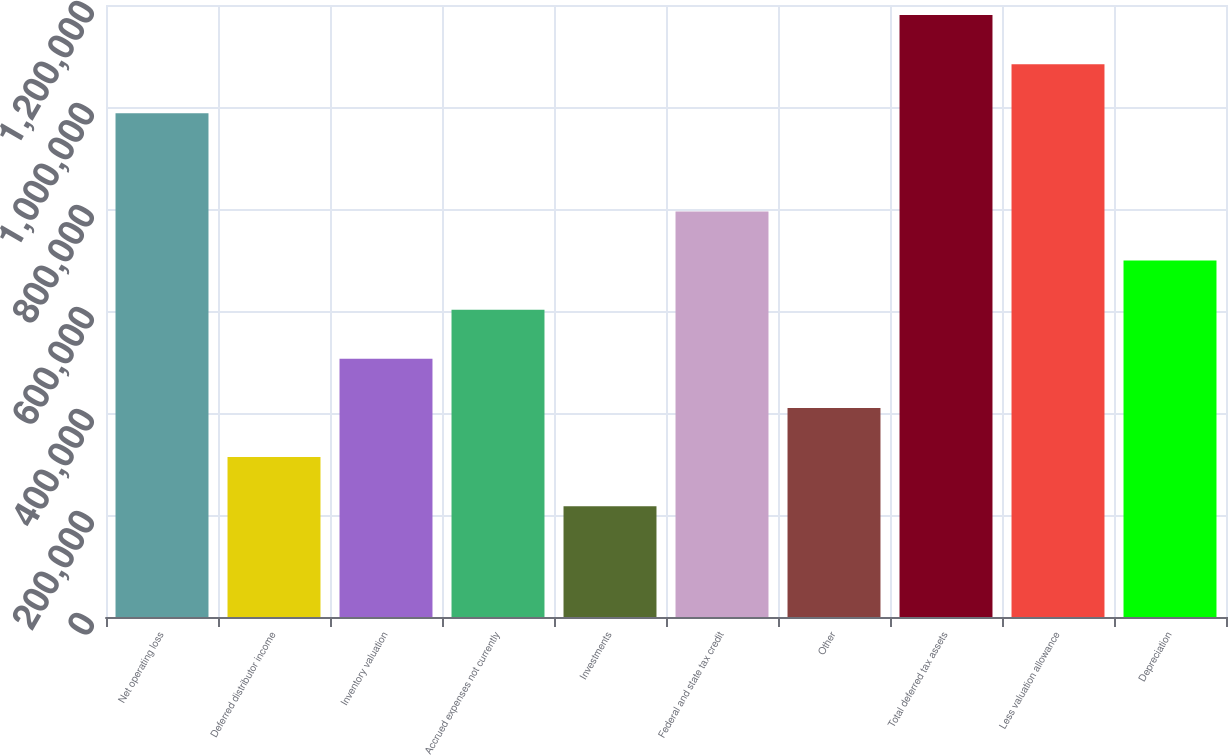<chart> <loc_0><loc_0><loc_500><loc_500><bar_chart><fcel>Net operating loss<fcel>Deferred distributor income<fcel>Inventory valuation<fcel>Accrued expenses not currently<fcel>Investments<fcel>Federal and state tax credit<fcel>Other<fcel>Total deferred tax assets<fcel>Less valuation allowance<fcel>Depreciation<nl><fcel>987710<fcel>313540<fcel>506160<fcel>602470<fcel>217230<fcel>795090<fcel>409850<fcel>1.18033e+06<fcel>1.08402e+06<fcel>698780<nl></chart> 